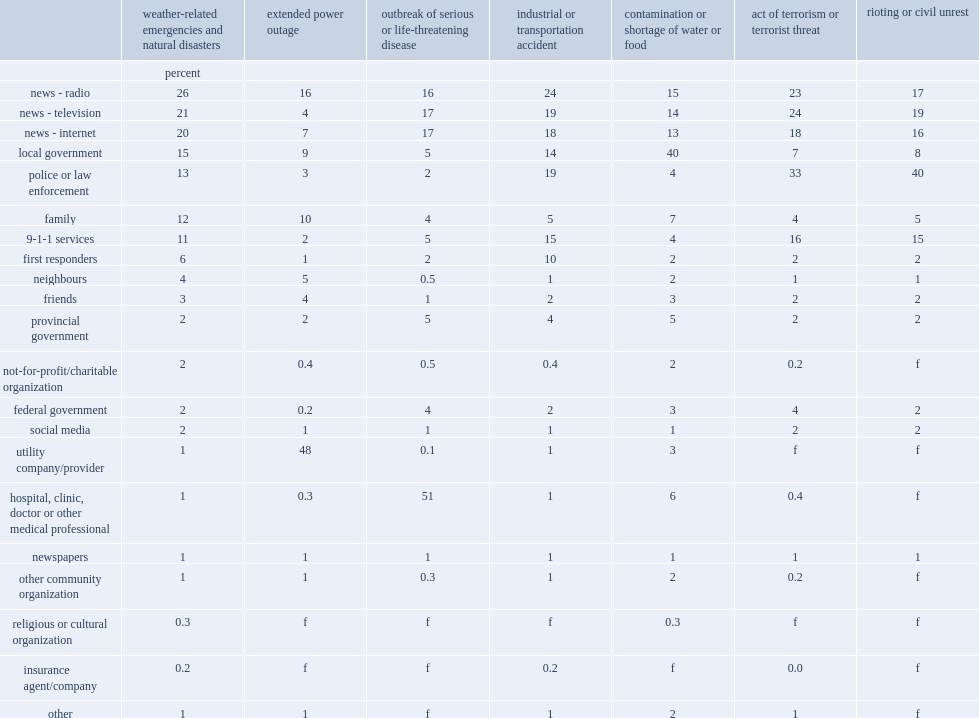According to the sepr, in a natural or weather-related disaster, what is the percentage of canadians in the provinces would first listen to the news on the radio for information or help in 2014? 26.0. What percentage would watch the news on television in a natural or weather-related disaster in 2014? 21.0. What percentage would seek out news sites on the internet in a natural or weather-related disaster in 2014.? 20.0. What is the percentage of the utility company was identified as the first source of information during a power outage, named by nearly half of canadians in 2014? 48.0. What is the percentage of listening to the news over the radio was identified as the first source of information during a power outage, named by nearly half of canadians in 2014? 16.0. Would you be able to parse every entry in this table? {'header': ['', 'weather-related emergencies and natural disasters', 'extended power outage', 'outbreak of serious or life-threatening disease', 'industrial or transportation accident', 'contamination or shortage of water or food', 'act of terrorism or terrorist threat', 'rioting or civil unrest'], 'rows': [['', 'percent', '', '', '', '', '', ''], ['news - radio', '26', '16', '16', '24', '15', '23', '17'], ['news - television', '21', '4', '17', '19', '14', '24', '19'], ['news - internet', '20', '7', '17', '18', '13', '18', '16'], ['local government', '15', '9', '5', '14', '40', '7', '8'], ['police or law enforcement', '13', '3', '2', '19', '4', '33', '40'], ['family', '12', '10', '4', '5', '7', '4', '5'], ['9-1-1 services', '11', '2', '5', '15', '4', '16', '15'], ['first responders', '6', '1', '2', '10', '2', '2', '2'], ['neighbours', '4', '5', '0.5', '1', '2', '1', '1'], ['friends', '3', '4', '1', '2', '3', '2', '2'], ['provincial government', '2', '2', '5', '4', '5', '2', '2'], ['not-for-profit/charitable organization', '2', '0.4', '0.5', '0.4', '2', '0.2', 'f'], ['federal government', '2', '0.2', '4', '2', '3', '4', '2'], ['social media', '2', '1', '1', '1', '1', '2', '2'], ['utility company/provider', '1', '48', '0.1', '1', '3', 'f', 'f'], ['hospital, clinic, doctor or other medical professional', '1', '0.3', '51', '1', '6', '0.4', 'f'], ['newspapers', '1', '1', '1', '1', '1', '1', '1'], ['other community organization', '1', '1', '0.3', '1', '2', '0.2', 'f'], ['religious or cultural organization', '0.3', 'f', 'f', 'f', '0.3', 'f', 'f'], ['insurance agent/company', '0.2', 'f', 'f', '0.2', 'f', '0.0', 'f'], ['other', '1', '1', 'f', '1', '2', '1', 'f']]} 